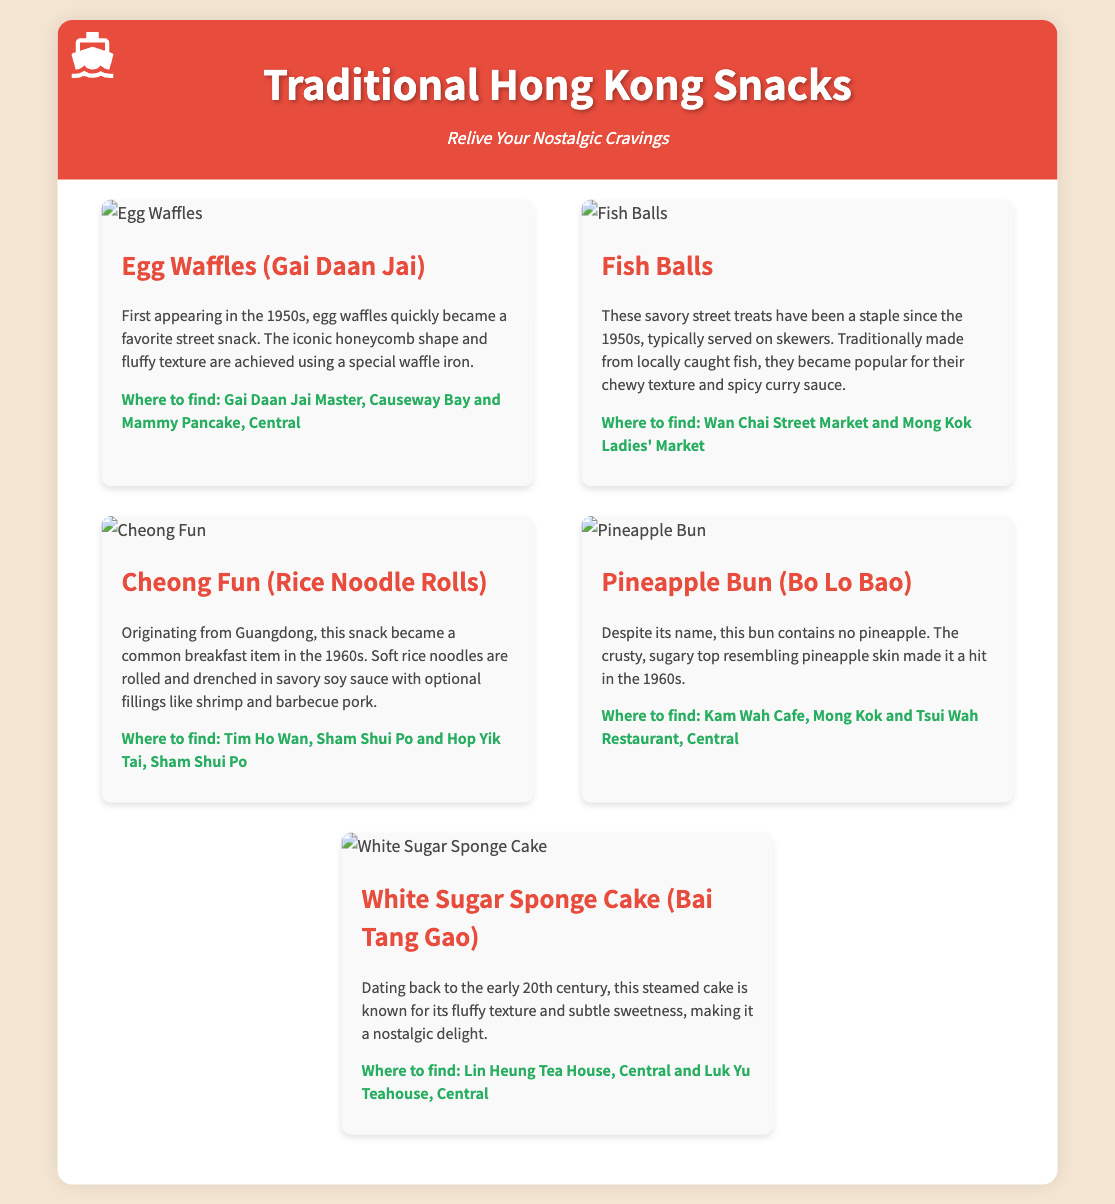What is the first snack listed? The first snack mentioned in the document is "Egg Waffles."
Answer: Egg Waffles In which decade did egg waffles first appear? The document states that egg waffles first appeared in the 1950s.
Answer: 1950s What snack is commonly found at Kam Wah Cafe? The document specifies that the "Pineapple Bun" is found at Kam Wah Cafe.
Answer: Pineapple Bun Which area is mentioned for finding Fish Balls? The document indicates that Fish Balls can be found at Wan Chai Street Market.
Answer: Wan Chai Street Market What unique feature do Pineapple Buns have? The text explains that Pineapple Buns have a crusty, sugary top resembling pineapple skin.
Answer: Sugary top resembling pineapple skin How is Cheong Fun typically served? The document describes Cheong Fun as being drenched in savory soy sauce.
Answer: Savory soy sauce What is the historical significance of White Sugar Sponge Cake? The document notes that it dates back to the early 20th century.
Answer: Early 20th century What is the common accompanying sauce for Fish Balls? The document mentions that Fish Balls are served with spicy curry sauce.
Answer: Spicy curry sauce 